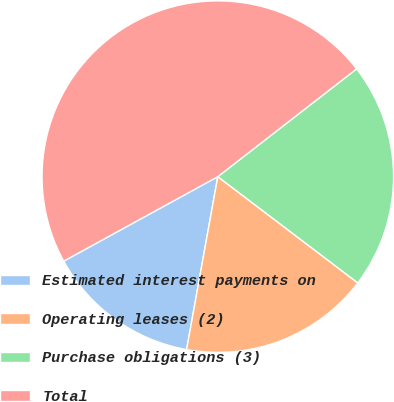Convert chart. <chart><loc_0><loc_0><loc_500><loc_500><pie_chart><fcel>Estimated interest payments on<fcel>Operating leases (2)<fcel>Purchase obligations (3)<fcel>Total<nl><fcel>14.18%<fcel>17.51%<fcel>20.84%<fcel>47.48%<nl></chart> 